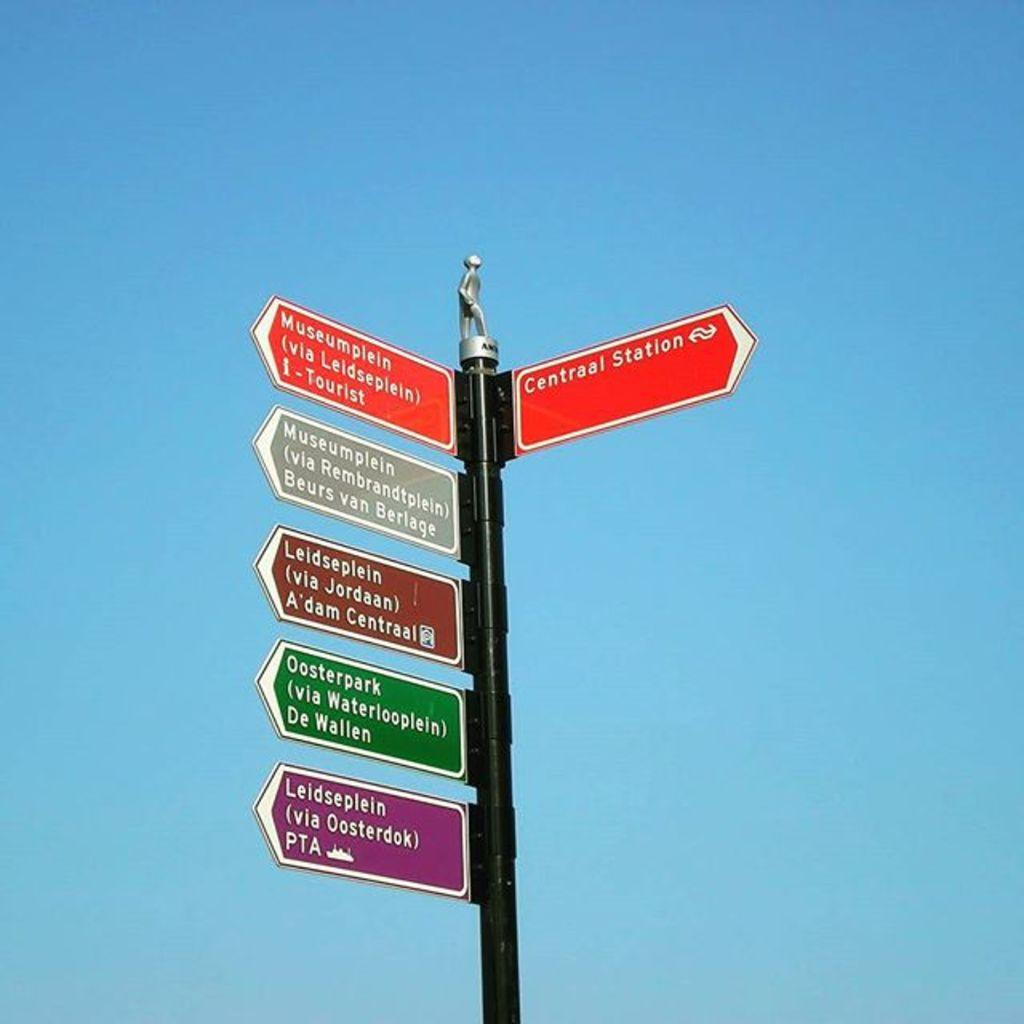<image>
Present a compact description of the photo's key features. the word centrall st that is on a pole 